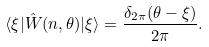Convert formula to latex. <formula><loc_0><loc_0><loc_500><loc_500>\langle \xi | \hat { W } ( n , \theta ) | \xi \rangle = \frac { \delta _ { 2 \pi } ( \theta - \xi ) } { 2 \pi } .</formula> 